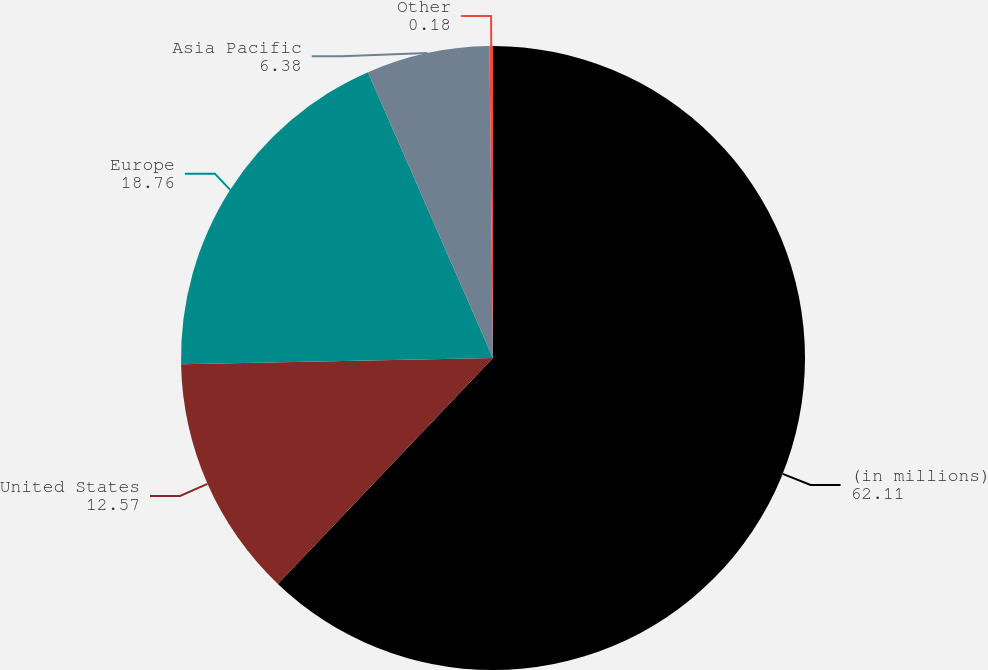Convert chart to OTSL. <chart><loc_0><loc_0><loc_500><loc_500><pie_chart><fcel>(in millions)<fcel>United States<fcel>Europe<fcel>Asia Pacific<fcel>Other<nl><fcel>62.11%<fcel>12.57%<fcel>18.76%<fcel>6.38%<fcel>0.18%<nl></chart> 